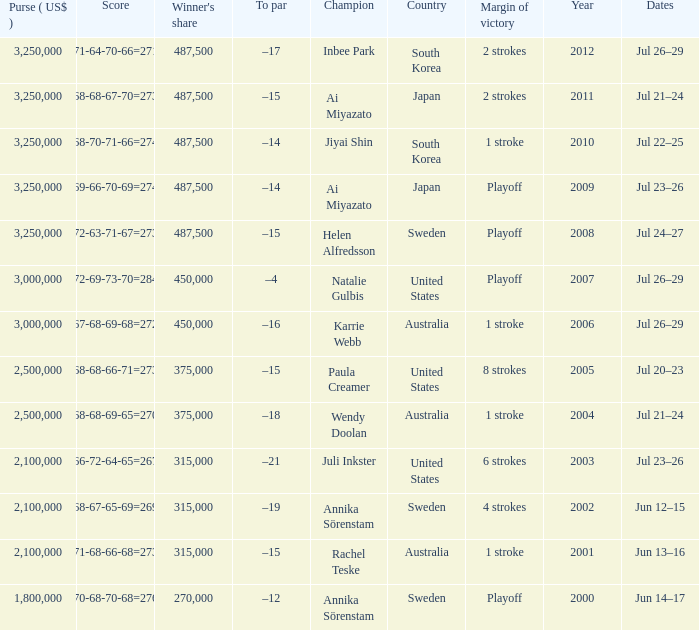Which Country has a Score of 70-68-70-68=276? Sweden. 